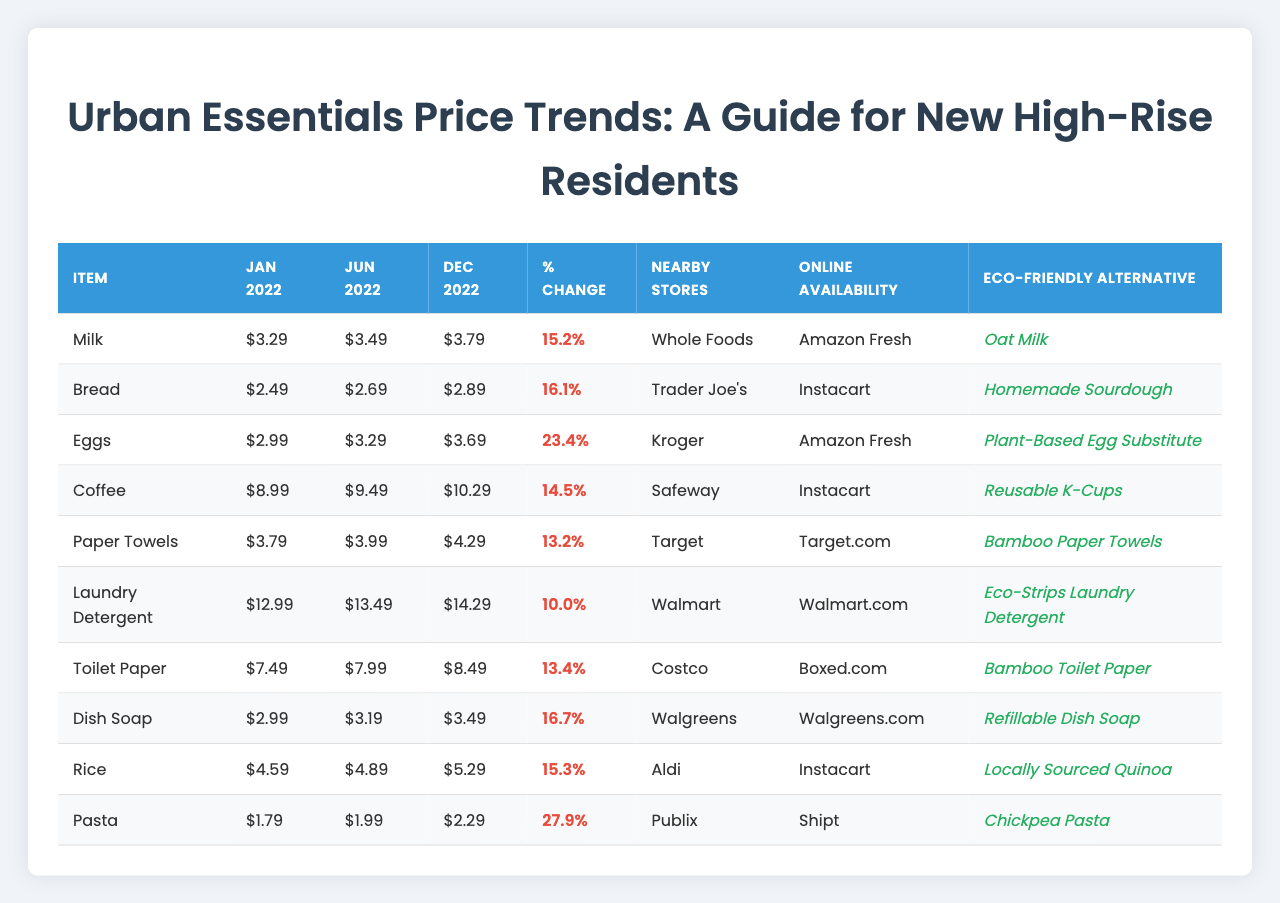What was the price of bread in December 2022? The table shows the price of bread for December 2022 as $2.89.
Answer: $2.89 Which item had the highest percentage increase in price? Looking at the "Percent Change (%)" column, pasta had the highest increase at 27.9%.
Answer: Pasta What is the January 2022 price of toilet paper? The table indicates that toilet paper was priced at $7.49 in January 2022.
Answer: $7.49 Which item had the lowest price in June 2022? By comparing the prices listed for June 2022, dish soap was the lowest at $3.19.
Answer: Dish Soap If you combine the January prices of milk and coffee, what is the total? Adding the prices of milk ($3.29) and coffee ($8.99) gives a total of $3.29 + $8.99 = $12.28.
Answer: $12.28 Did the price of laundry detergent decrease from January 2022 to December 2022? By checking the prices, laundry detergent went from $12.99 in January 2022 to $14.29 in December 2022, indicating an increase.
Answer: No What is the average price change for all items from January 2022 to December 2022? The total percentage change can be calculated by summing the percent changes (15.2 + 16.1 + 23.4 + 14.5 + 13.2 + 10.0 + 13.4 + 16.7 + 15.3 + 27.9 =  180.7) and dividing by the number of items (10), resulting in an average of 180.7 / 10 = 18.07%.
Answer: 18.07% Which eco-friendly alternative is suggested for rice? The table specifies "Locally Sourced Quinoa" as the eco-friendly alternative for rice.
Answer: Locally Sourced Quinoa Was the price of coffee higher than the price of eggs in December 2022? The December 2022 price of coffee is $10.29, while eggs are $3.69, showing that coffee was indeed higher.
Answer: Yes How many items are available for purchase online? Each item listed in the table has an online availability option, totaling 10 items.
Answer: 10 